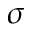Convert formula to latex. <formula><loc_0><loc_0><loc_500><loc_500>\sigma</formula> 